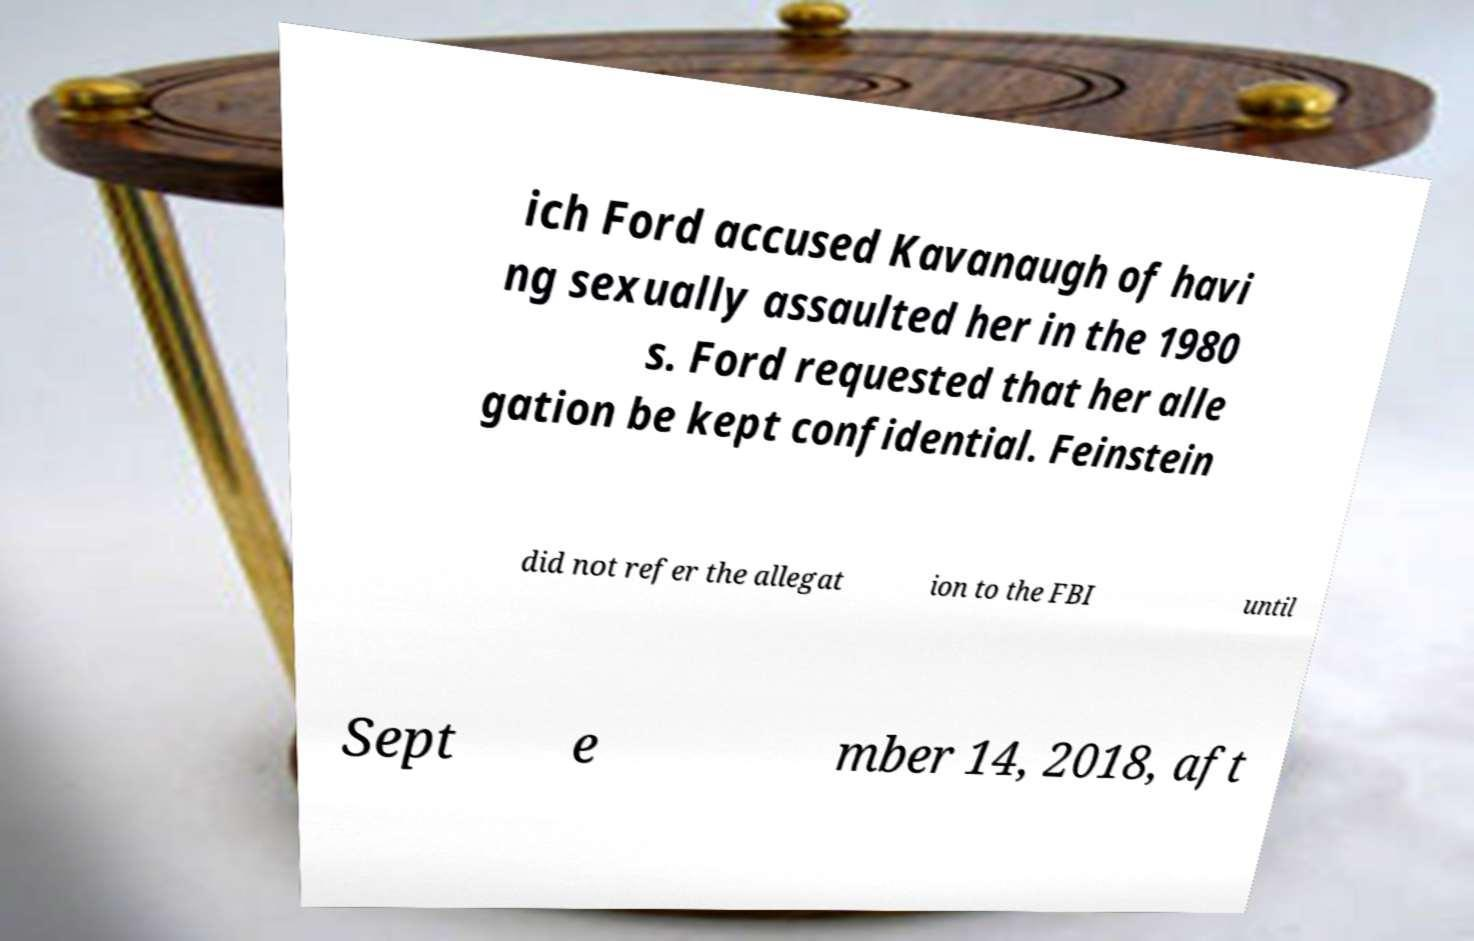Could you assist in decoding the text presented in this image and type it out clearly? ich Ford accused Kavanaugh of havi ng sexually assaulted her in the 1980 s. Ford requested that her alle gation be kept confidential. Feinstein did not refer the allegat ion to the FBI until Sept e mber 14, 2018, aft 